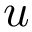Convert formula to latex. <formula><loc_0><loc_0><loc_500><loc_500>u</formula> 